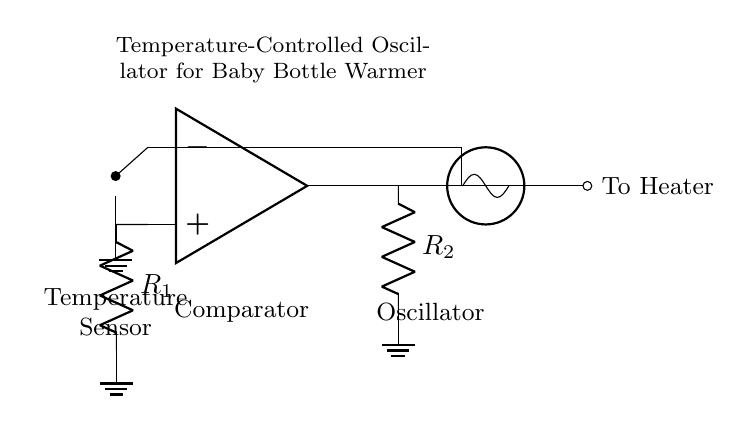What type of sensor is used in this circuit? The circuit diagram shows a thermistor, which is typically used for measuring temperature. It converts temperature changes into resistance variations.
Answer: Thermistor What component compares the temperature sensor’s output? The operational amplifier serves as a comparator by comparing the input from the thermistor with a reference voltage to decide when to activate the oscillator.
Answer: Operational amplifier What is the purpose of the feedback network? The feedback network, consisting of resistor R2, helps stabilize the oscillator by providing a portion of the output signal back to the input, allowing for controlled oscillation based on temperature changes.
Answer: Stabilization How many resistors are present in this circuit? The circuit includes two resistors, noted as R1 and R2, which are part of the feedback and reference voltage configuration.
Answer: Two What is the final output of the oscillator? The output of the oscillator is directed to the heater, which receives the control signal for warming the baby bottle based on temperature feedback.
Answer: To heater Why is an oscillator used in this circuit? An oscillator is used to generate a regular output signal that controls the heater intermittently, preventing overheating and maintaining a stable temperature for the baby bottle.
Answer: To control heater operation 